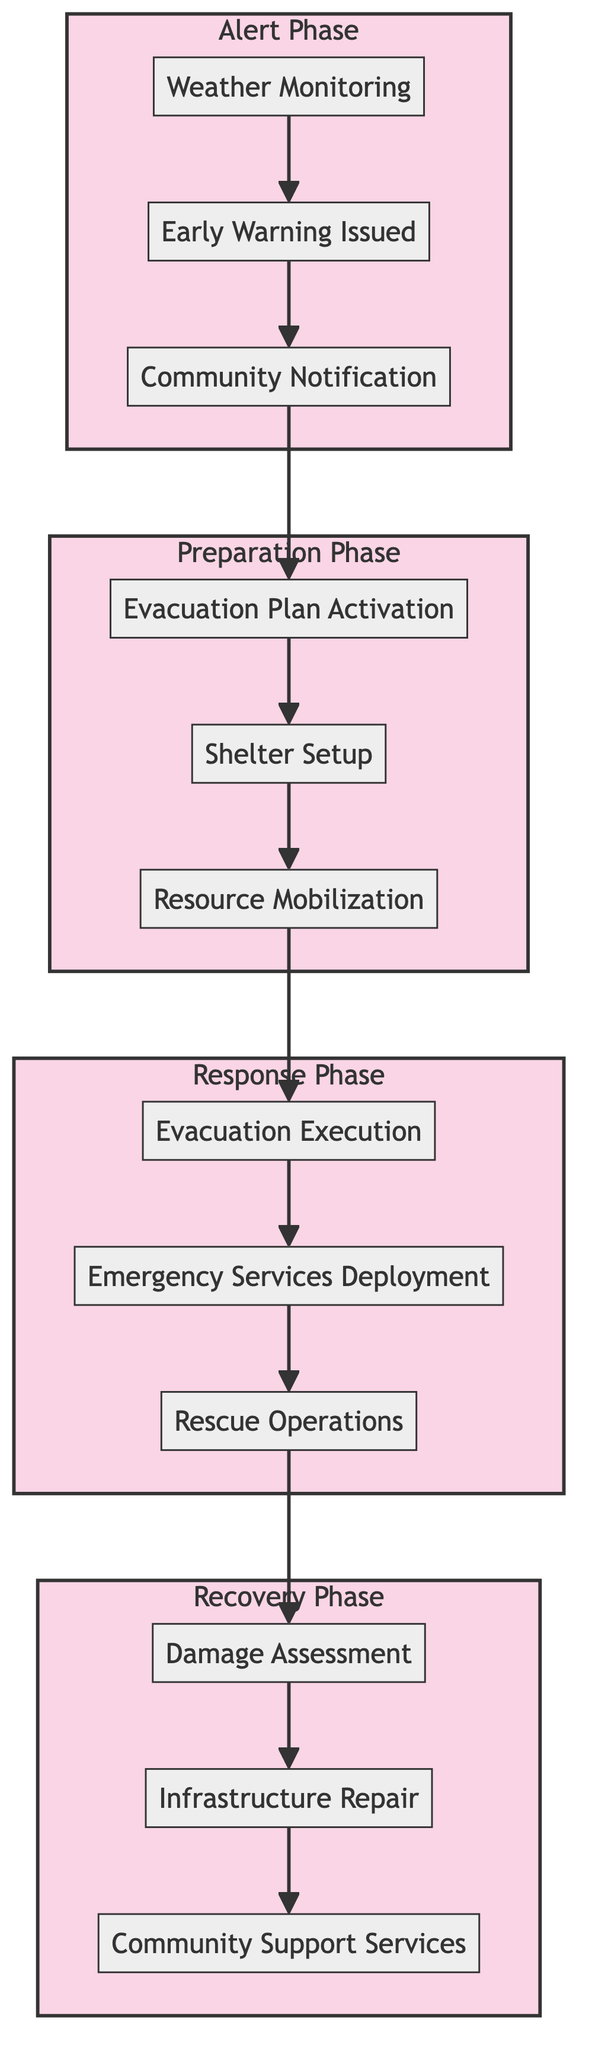What are the three steps in the Alert phase? The Alert phase consists of three steps: Weather Monitoring, Early Warning Issued, and Community Notification. These steps are directly listed under the Alert phase in the diagram.
Answer: Weather Monitoring, Early Warning Issued, Community Notification How many phases are there in the Emergency Response Process? The diagram has four phases: Alert, Preparation, Response, and Recovery. This can be verified by counting the subgraphs representing each phase in the flow chart.
Answer: Four What is the first step in the Preparation phase? The first step in the Preparation phase is Evacuation Plan Activation. This is identified by looking at the flow from the Alert phase to the Preparation phase, where it begins with that step.
Answer: Evacuation Plan Activation Which step follows Community Notification? The next step after Community Notification is Evacuation Plan Activation. This relationship is shown by the directed arrow connecting those two steps in the flow chart.
Answer: Evacuation Plan Activation What is the final step in the Recovery phase? The final step in the Recovery phase is Community Support Services. This is the last step listed in the corresponding subgraph of the Recovery phase.
Answer: Community Support Services How many steps are in the Response phase? The Response phase has three steps: Evacuation Execution, Emergency Services Deployment, and Rescue Operations. The number of steps can be counted from the diagram's listing under that specific phase.
Answer: Three What happens after Rescue Operations? After Rescue Operations, the next step is Damage Assessment. This is determined by following the directional arrows from the Response phase to the Recovery phase.
Answer: Damage Assessment What are the steps involved in the Recovery phase? The Recovery phase includes three steps: Damage Assessment, Infrastructure Repair, and Community Support Services. This is explicitly stated under the Recovery phase in the flow chart.
Answer: Damage Assessment, Infrastructure Repair, Community Support Services 